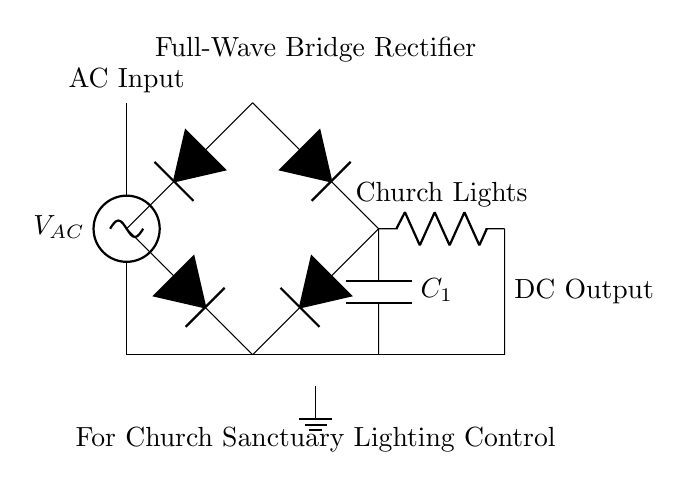What type of rectifier is used in this circuit? The circuit uses a full-wave bridge rectifier, which is indicated by the arrangement of four diodes forming a bridge. This allows current to pass through both halves of the AC waveform, producing a smoother DC output.
Answer: full-wave bridge rectifier How many diodes are in this rectifier? The diagram shows four diodes arranged in a bridge configuration. This is characteristic of a bridge rectifier, where each diode conducts during alternate half-cycles of the AC input.
Answer: four What is the purpose of the capacitor in this circuit? The capacitor smooths out the rectified DC signal by reducing voltage ripple. It charges when the voltage increases and discharges when the voltage falls, providing a more consistent output voltage for the load.
Answer: smoothing What type of load is connected to this circuit? The load connected is labeled 'Church Lights', which implies the circuit is designed to control lighting solutions in a church sanctuary. This indicates the purpose of the rectified and smoothed DC power supply.
Answer: Church Lights What is connected to the ground in this circuit? A ground connection is shown at the bottom of the diagram, providing a reference point for the circuit and ensuring safety by preventing buildup of excess voltage. This is crucial for any electrical installation.
Answer: ground What is the expected voltage output type from this circuit? The circuit is designed to convert AC voltage from the source into DC voltage for the load. Since this is a rectifier circuit, the output at the load will be positive DC voltage suitable for the lighting.
Answer: DC output 